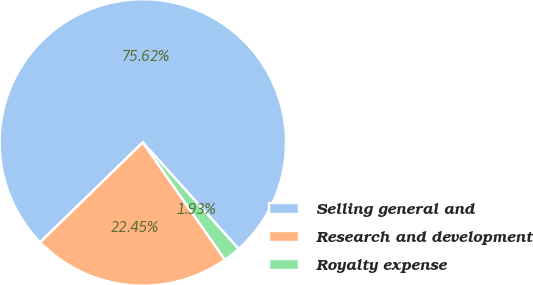Convert chart to OTSL. <chart><loc_0><loc_0><loc_500><loc_500><pie_chart><fcel>Selling general and<fcel>Research and development<fcel>Royalty expense<nl><fcel>75.62%<fcel>22.45%<fcel>1.93%<nl></chart> 